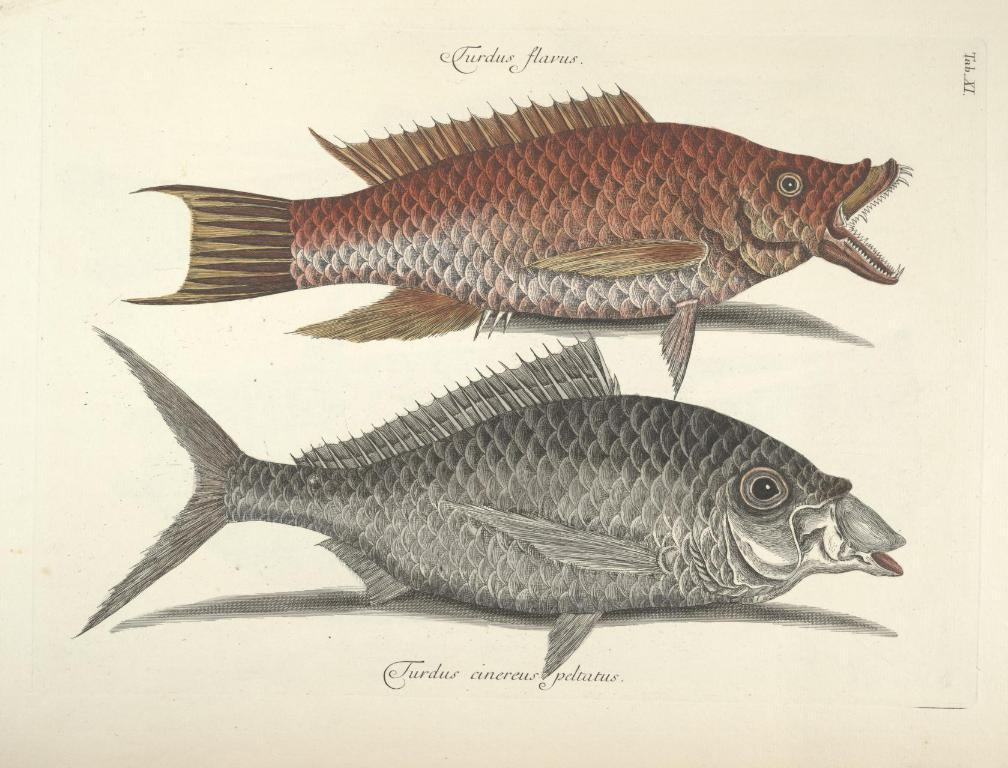What type of drawings can be seen in the image? There are drawings of fishes in the image. Is there any text or writing in the image? Yes, there is writing on the image. What type of bead is used to create the drawings of the fishes? There is no mention of beads being used in the image; the drawings are likely created using a pen, pencil, or other drawing tool. 